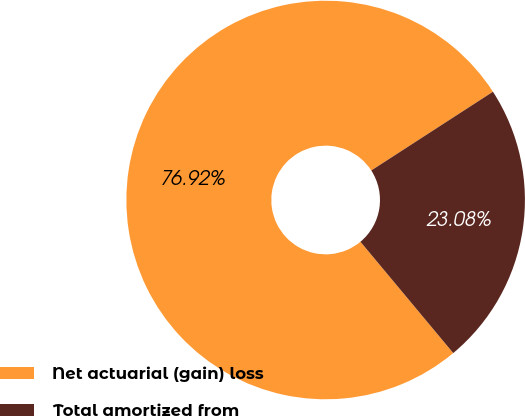Convert chart to OTSL. <chart><loc_0><loc_0><loc_500><loc_500><pie_chart><fcel>Net actuarial (gain) loss<fcel>Total amortized from<nl><fcel>76.92%<fcel>23.08%<nl></chart> 